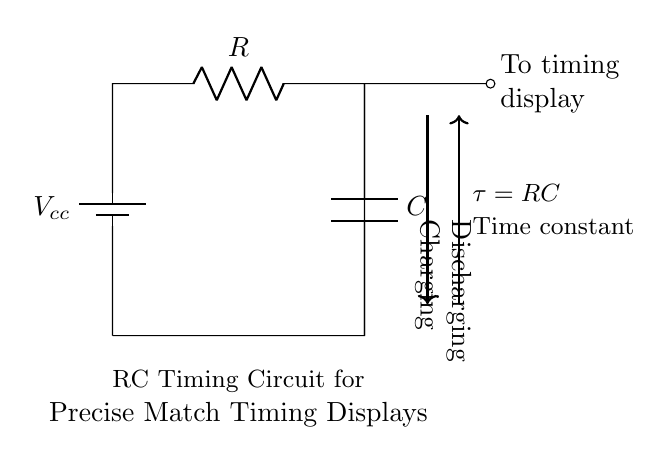What type of circuit is shown? The circuit is an RC timing circuit, which consists of a resistor and a capacitor arranged in a way to determine a specific timing interval based on the values of these components.
Answer: RC timing circuit What is the role of the capacitor? The capacitor in this circuit stores electrical energy and releases it, which is essential for timing functions as it influences the timing duration based on how quickly it charges and discharges.
Answer: Energy storage What does the time constant (tau) represent? The time constant (tau) represents the time it takes for the capacitor to charge to approximately 63.2% of the supply voltage, and it is calculated by multiplying the resistance and capacitance values.
Answer: RC What happens during the charging phase? During the charging phase, the capacitor gradually accumulates voltage until it reaches the supply voltage level, affecting the timing display connected to the circuit.
Answer: Voltage accumulation How does increasing resistance affect the time constant? Increasing the resistance results in a larger time constant, which causes the capacitor to charge and discharge more slowly, thus extending the timing interval for the display.
Answer: Increases timing What voltage is being supplied to the circuit? The voltage supplied to the circuit is denoted as Vcc, and it represents the power source feeding the circuit with electrical energy.
Answer: Vcc What is the significance of the display connected to the circuit? The display connected to the circuit is significant because it shows the timing results or outputs derived from the RC charging and discharging processes, useful for tracking match timings.
Answer: Timing display 